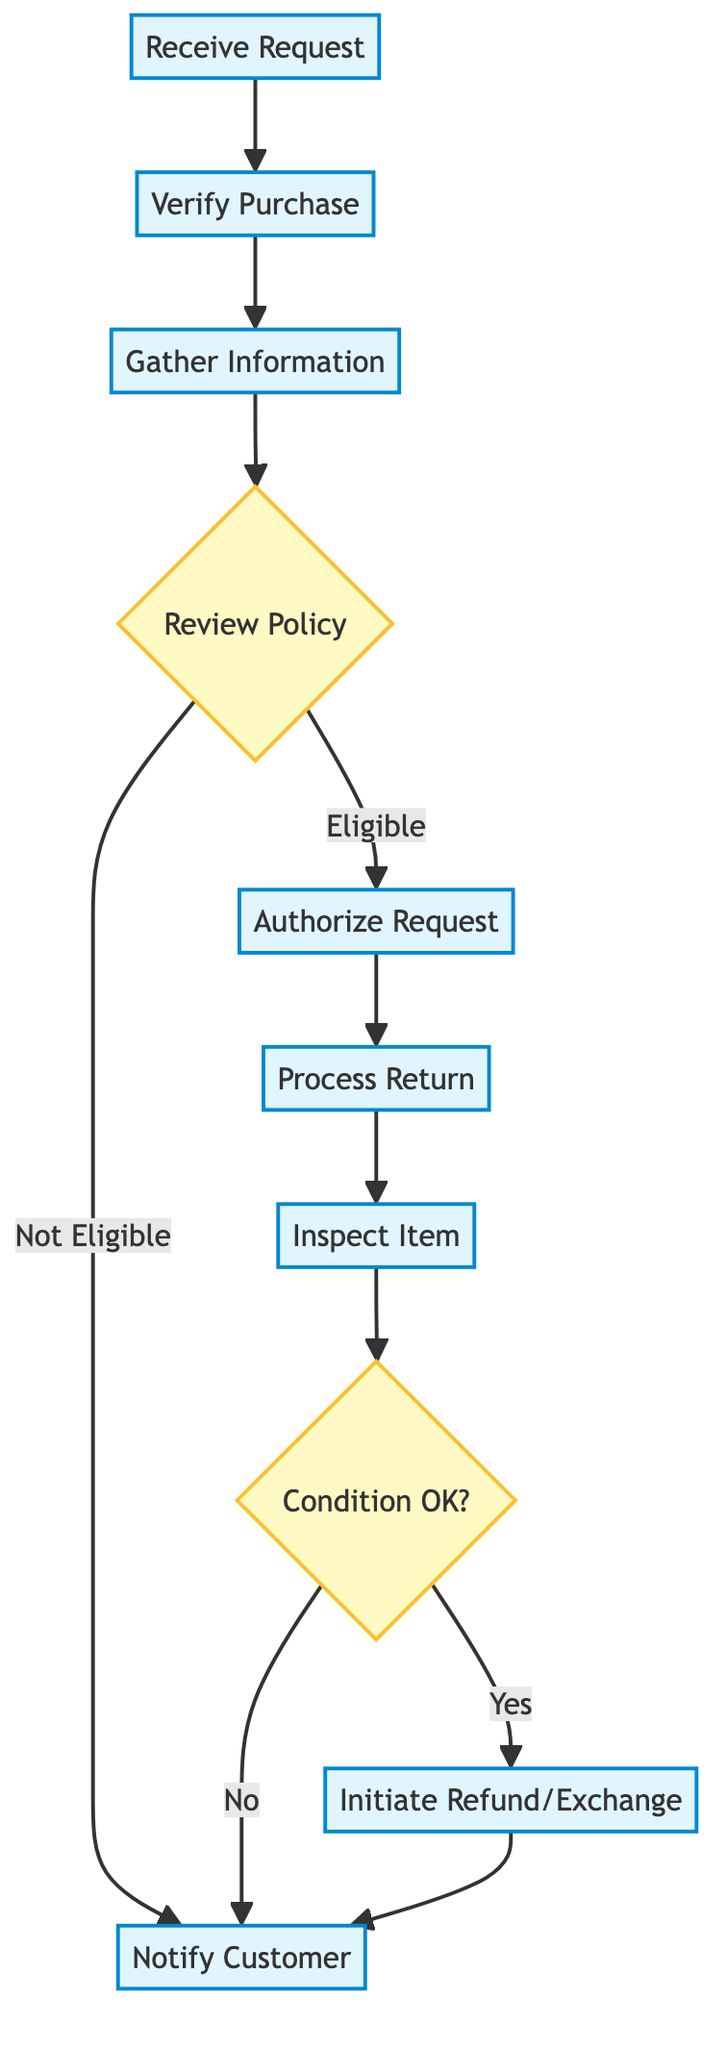What is the first step in the refund process? The first step shown in the diagram is "Receive Request", which indicates that the customer contacts support to initiate a refund or exchange.
Answer: Receive Request How many decision points are in the diagram? The diagram includes two decision points: "Review Policy" and "Condition OK?". Therefore, by counting them, we find there are two decision nodes.
Answer: 2 What happens if the purchase is not eligible for a refund or exchange? According to the diagram, if the purchase is not eligible (as indicated in the "Review Policy" step), the flow leads to the "Notify Customer" step, which informs the customer about the ineligibility.
Answer: Notify Customer What is provided to the customer if the request is eligible? If the request is eligible, the diagram illustrates that the customer is provided with a return authorization number (RAN) in the "Authorize Request" step.
Answer: Return Authorization Number How does one determine if the item is in the right condition? The "Inspect Item" node leads to a decision point "Condition OK?", where a yes or no decision is made based on the item's compliance with the return policy. If the condition is OK, the process continues to initiate the refund or exchange.
Answer: Condition OK? What triggers the item inspection step? The item inspection step, labeled "Inspect Item", is triggered by the completion of the "Process Return" step, which indicates that the returned item has been received.
Answer: Process Return If the item condition is not okay, what is the next step? If the item fails the condition check in the "Inspect Item" step, the flow goes to "Notify Customer", confirming the failure to meet return conditions.
Answer: Notify Customer How many steps are there in the refund process? Counting the steps in the diagram, there are a total of nine distinct steps detailing the refund process, ranging from the initial request to customer notification.
Answer: 9 What step follows after "Gather Information"? The step that follows the "Gather Information" is "Review Policy", where the eligibility of the refund or exchange request is evaluated against company policy.
Answer: Review Policy 